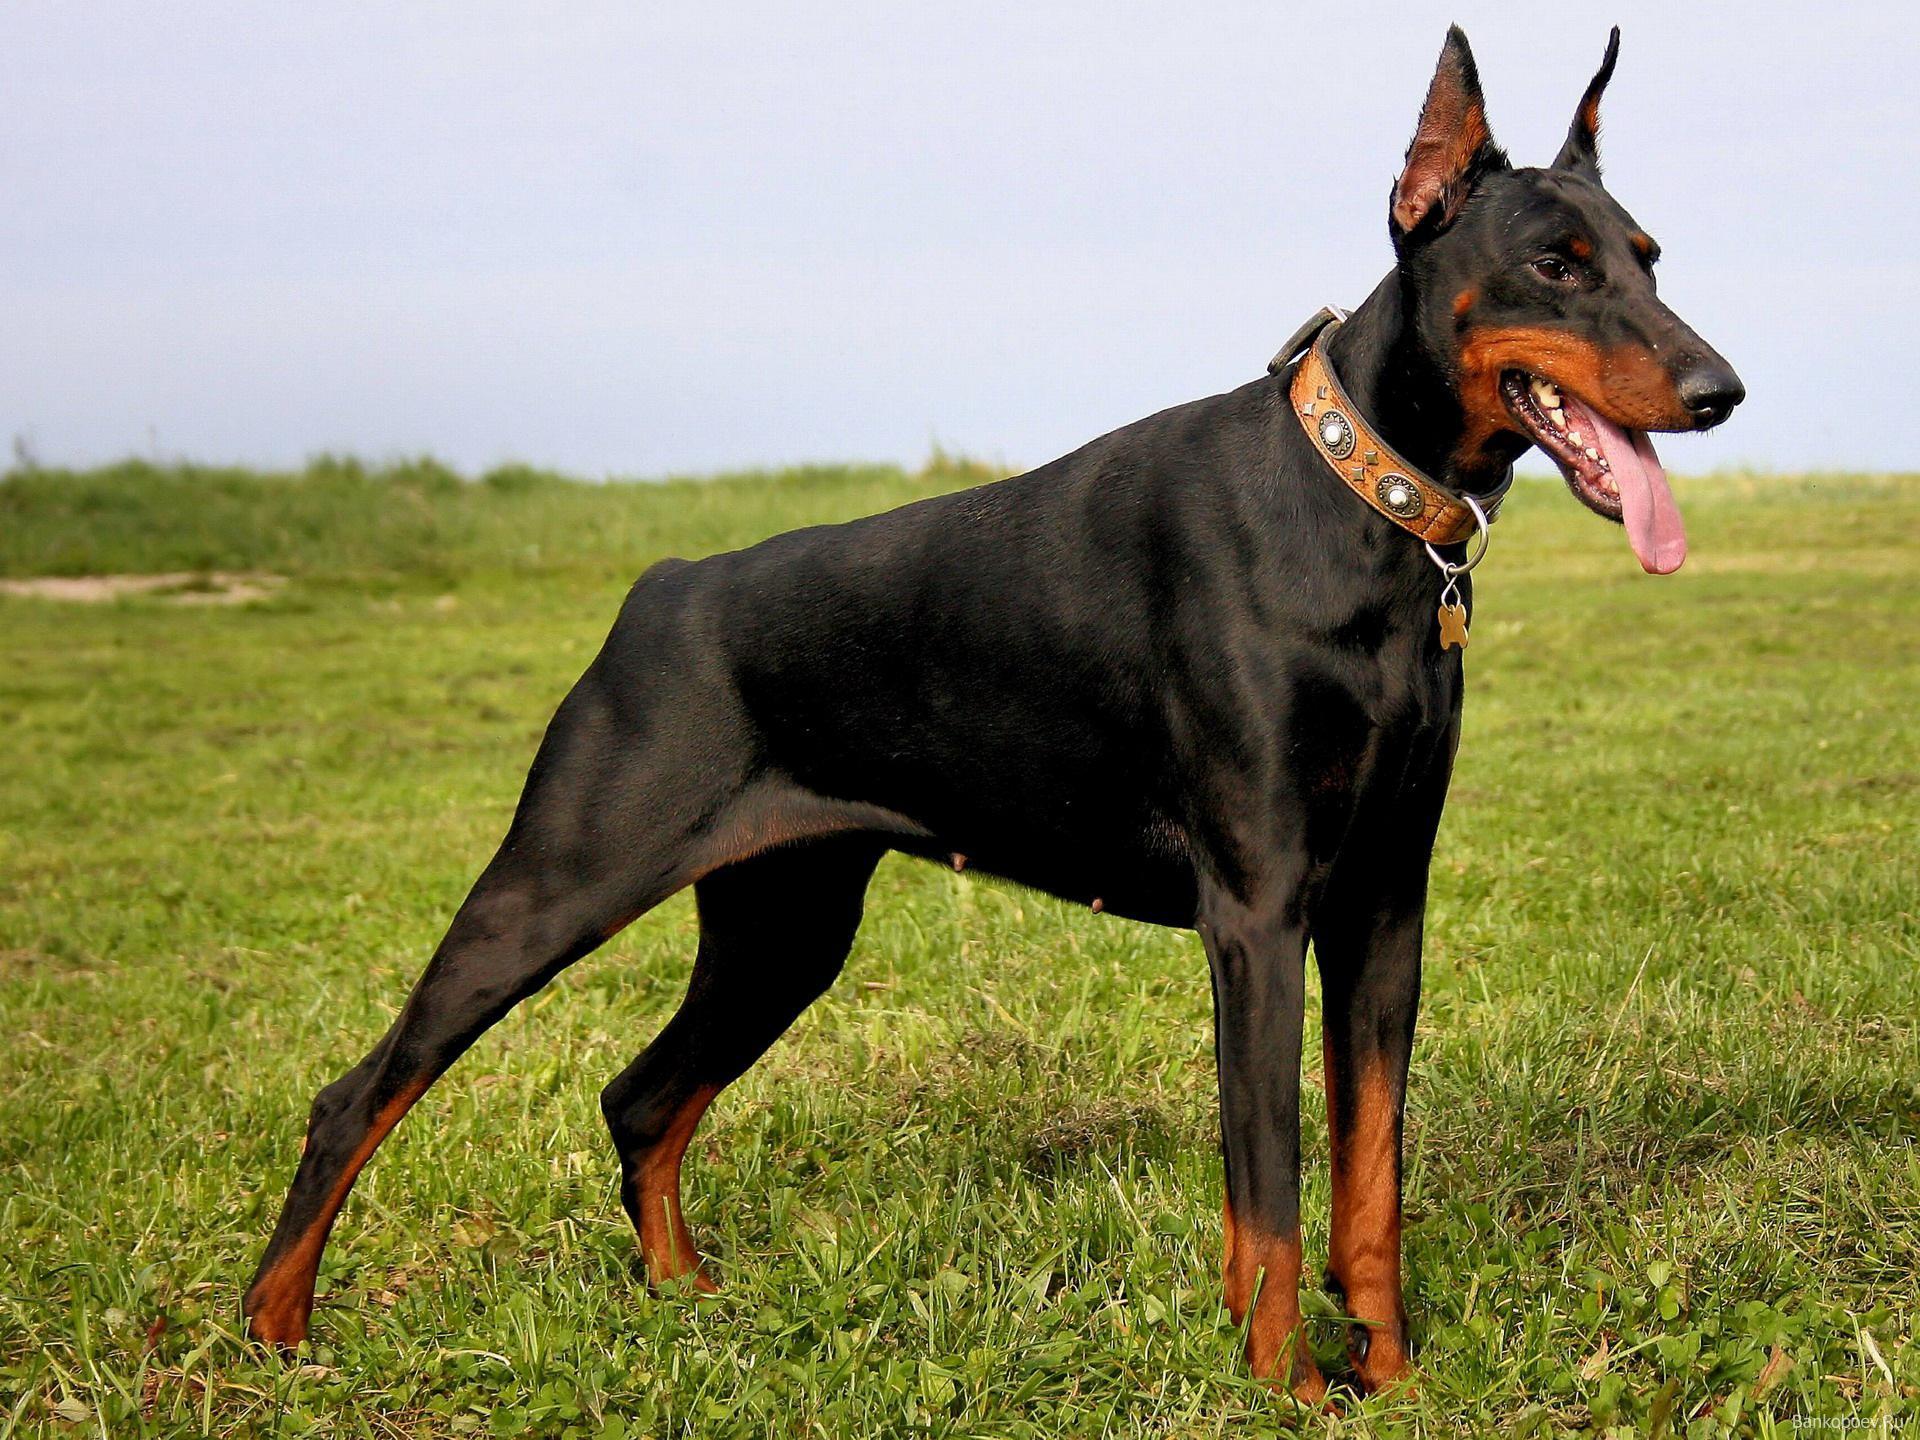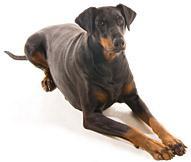The first image is the image on the left, the second image is the image on the right. Examine the images to the left and right. Is the description "There are three dogs." accurate? Answer yes or no. No. The first image is the image on the left, the second image is the image on the right. Examine the images to the left and right. Is the description "A total of three dogs, all standing, are shown, and at least two dogs are dobermans with erect pointy ears." accurate? Answer yes or no. No. 